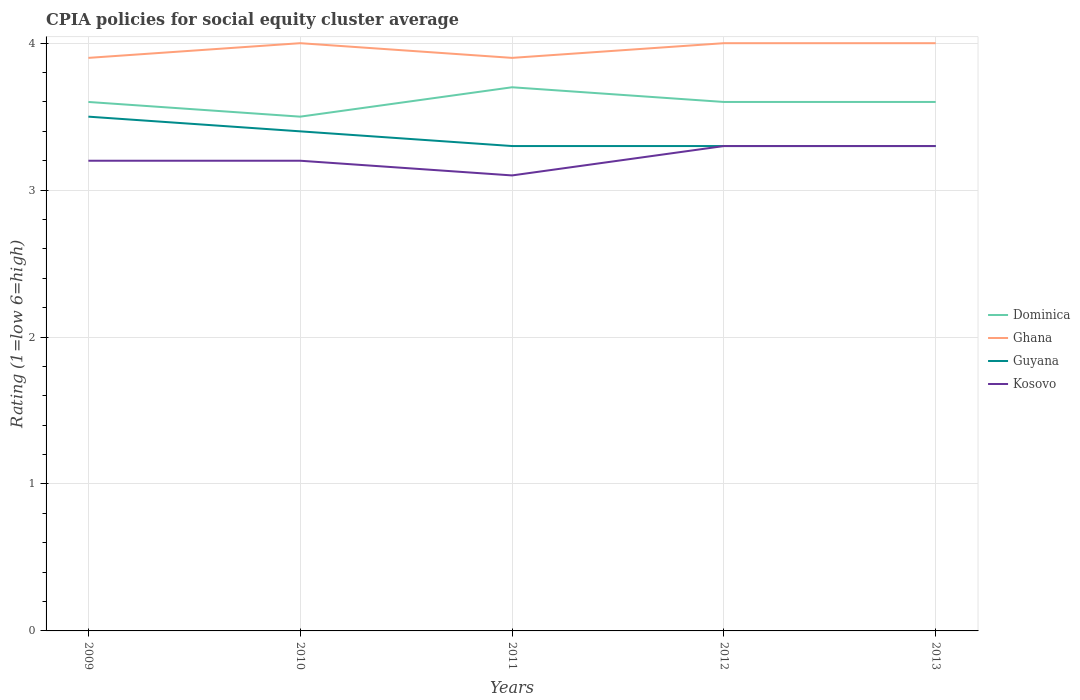Does the line corresponding to Ghana intersect with the line corresponding to Kosovo?
Make the answer very short. No. Is the number of lines equal to the number of legend labels?
Your answer should be compact. Yes. Across all years, what is the maximum CPIA rating in Dominica?
Provide a succinct answer. 3.5. What is the total CPIA rating in Ghana in the graph?
Ensure brevity in your answer.  0. What is the difference between the highest and the second highest CPIA rating in Guyana?
Your response must be concise. 0.2. What is the difference between the highest and the lowest CPIA rating in Kosovo?
Provide a succinct answer. 2. How many years are there in the graph?
Offer a very short reply. 5. Are the values on the major ticks of Y-axis written in scientific E-notation?
Your answer should be very brief. No. Does the graph contain any zero values?
Give a very brief answer. No. What is the title of the graph?
Offer a very short reply. CPIA policies for social equity cluster average. What is the Rating (1=low 6=high) of Guyana in 2009?
Offer a very short reply. 3.5. What is the Rating (1=low 6=high) of Dominica in 2010?
Your answer should be compact. 3.5. What is the Rating (1=low 6=high) in Ghana in 2011?
Your answer should be very brief. 3.9. What is the Rating (1=low 6=high) of Guyana in 2011?
Your answer should be very brief. 3.3. What is the Rating (1=low 6=high) of Dominica in 2012?
Give a very brief answer. 3.6. What is the Rating (1=low 6=high) of Guyana in 2012?
Provide a succinct answer. 3.3. What is the Rating (1=low 6=high) of Kosovo in 2012?
Your response must be concise. 3.3. What is the Rating (1=low 6=high) in Dominica in 2013?
Provide a short and direct response. 3.6. What is the Rating (1=low 6=high) of Kosovo in 2013?
Ensure brevity in your answer.  3.3. Across all years, what is the maximum Rating (1=low 6=high) of Guyana?
Give a very brief answer. 3.5. Across all years, what is the maximum Rating (1=low 6=high) of Kosovo?
Provide a succinct answer. 3.3. Across all years, what is the minimum Rating (1=low 6=high) in Dominica?
Offer a terse response. 3.5. Across all years, what is the minimum Rating (1=low 6=high) in Ghana?
Ensure brevity in your answer.  3.9. What is the total Rating (1=low 6=high) in Ghana in the graph?
Your answer should be compact. 19.8. What is the total Rating (1=low 6=high) of Kosovo in the graph?
Provide a succinct answer. 16.1. What is the difference between the Rating (1=low 6=high) in Dominica in 2009 and that in 2010?
Offer a very short reply. 0.1. What is the difference between the Rating (1=low 6=high) of Ghana in 2009 and that in 2010?
Give a very brief answer. -0.1. What is the difference between the Rating (1=low 6=high) in Kosovo in 2009 and that in 2010?
Offer a very short reply. 0. What is the difference between the Rating (1=low 6=high) of Dominica in 2009 and that in 2011?
Keep it short and to the point. -0.1. What is the difference between the Rating (1=low 6=high) in Guyana in 2009 and that in 2011?
Your response must be concise. 0.2. What is the difference between the Rating (1=low 6=high) of Dominica in 2009 and that in 2012?
Provide a short and direct response. 0. What is the difference between the Rating (1=low 6=high) of Ghana in 2009 and that in 2013?
Give a very brief answer. -0.1. What is the difference between the Rating (1=low 6=high) in Ghana in 2010 and that in 2011?
Ensure brevity in your answer.  0.1. What is the difference between the Rating (1=low 6=high) of Guyana in 2010 and that in 2011?
Your response must be concise. 0.1. What is the difference between the Rating (1=low 6=high) in Dominica in 2010 and that in 2012?
Offer a very short reply. -0.1. What is the difference between the Rating (1=low 6=high) in Dominica in 2010 and that in 2013?
Offer a very short reply. -0.1. What is the difference between the Rating (1=low 6=high) of Ghana in 2010 and that in 2013?
Your answer should be very brief. 0. What is the difference between the Rating (1=low 6=high) of Kosovo in 2010 and that in 2013?
Keep it short and to the point. -0.1. What is the difference between the Rating (1=low 6=high) of Ghana in 2011 and that in 2012?
Offer a terse response. -0.1. What is the difference between the Rating (1=low 6=high) of Guyana in 2011 and that in 2013?
Your answer should be very brief. 0. What is the difference between the Rating (1=low 6=high) of Dominica in 2012 and that in 2013?
Offer a terse response. 0. What is the difference between the Rating (1=low 6=high) of Kosovo in 2012 and that in 2013?
Offer a terse response. 0. What is the difference between the Rating (1=low 6=high) of Dominica in 2009 and the Rating (1=low 6=high) of Kosovo in 2010?
Give a very brief answer. 0.4. What is the difference between the Rating (1=low 6=high) in Ghana in 2009 and the Rating (1=low 6=high) in Kosovo in 2010?
Ensure brevity in your answer.  0.7. What is the difference between the Rating (1=low 6=high) of Guyana in 2009 and the Rating (1=low 6=high) of Kosovo in 2010?
Make the answer very short. 0.3. What is the difference between the Rating (1=low 6=high) in Dominica in 2009 and the Rating (1=low 6=high) in Ghana in 2011?
Offer a terse response. -0.3. What is the difference between the Rating (1=low 6=high) in Dominica in 2009 and the Rating (1=low 6=high) in Kosovo in 2011?
Provide a short and direct response. 0.5. What is the difference between the Rating (1=low 6=high) in Ghana in 2009 and the Rating (1=low 6=high) in Kosovo in 2011?
Provide a succinct answer. 0.8. What is the difference between the Rating (1=low 6=high) in Guyana in 2009 and the Rating (1=low 6=high) in Kosovo in 2011?
Make the answer very short. 0.4. What is the difference between the Rating (1=low 6=high) in Dominica in 2009 and the Rating (1=low 6=high) in Ghana in 2012?
Provide a succinct answer. -0.4. What is the difference between the Rating (1=low 6=high) in Dominica in 2009 and the Rating (1=low 6=high) in Guyana in 2012?
Offer a terse response. 0.3. What is the difference between the Rating (1=low 6=high) in Ghana in 2009 and the Rating (1=low 6=high) in Guyana in 2012?
Give a very brief answer. 0.6. What is the difference between the Rating (1=low 6=high) in Dominica in 2009 and the Rating (1=low 6=high) in Ghana in 2013?
Give a very brief answer. -0.4. What is the difference between the Rating (1=low 6=high) of Dominica in 2009 and the Rating (1=low 6=high) of Guyana in 2013?
Your answer should be compact. 0.3. What is the difference between the Rating (1=low 6=high) in Ghana in 2009 and the Rating (1=low 6=high) in Guyana in 2013?
Make the answer very short. 0.6. What is the difference between the Rating (1=low 6=high) in Dominica in 2010 and the Rating (1=low 6=high) in Guyana in 2011?
Your answer should be compact. 0.2. What is the difference between the Rating (1=low 6=high) in Dominica in 2010 and the Rating (1=low 6=high) in Guyana in 2012?
Ensure brevity in your answer.  0.2. What is the difference between the Rating (1=low 6=high) in Ghana in 2010 and the Rating (1=low 6=high) in Kosovo in 2012?
Provide a succinct answer. 0.7. What is the difference between the Rating (1=low 6=high) of Guyana in 2010 and the Rating (1=low 6=high) of Kosovo in 2012?
Give a very brief answer. 0.1. What is the difference between the Rating (1=low 6=high) in Dominica in 2010 and the Rating (1=low 6=high) in Kosovo in 2013?
Provide a succinct answer. 0.2. What is the difference between the Rating (1=low 6=high) of Ghana in 2010 and the Rating (1=low 6=high) of Guyana in 2013?
Your answer should be compact. 0.7. What is the difference between the Rating (1=low 6=high) of Ghana in 2010 and the Rating (1=low 6=high) of Kosovo in 2013?
Keep it short and to the point. 0.7. What is the difference between the Rating (1=low 6=high) in Dominica in 2011 and the Rating (1=low 6=high) in Ghana in 2012?
Offer a terse response. -0.3. What is the difference between the Rating (1=low 6=high) in Ghana in 2011 and the Rating (1=low 6=high) in Guyana in 2012?
Your response must be concise. 0.6. What is the difference between the Rating (1=low 6=high) of Dominica in 2011 and the Rating (1=low 6=high) of Ghana in 2013?
Provide a succinct answer. -0.3. What is the difference between the Rating (1=low 6=high) of Dominica in 2011 and the Rating (1=low 6=high) of Guyana in 2013?
Your response must be concise. 0.4. What is the difference between the Rating (1=low 6=high) in Ghana in 2011 and the Rating (1=low 6=high) in Guyana in 2013?
Offer a terse response. 0.6. What is the difference between the Rating (1=low 6=high) of Ghana in 2011 and the Rating (1=low 6=high) of Kosovo in 2013?
Provide a short and direct response. 0.6. What is the difference between the Rating (1=low 6=high) of Guyana in 2011 and the Rating (1=low 6=high) of Kosovo in 2013?
Your response must be concise. 0. What is the difference between the Rating (1=low 6=high) of Dominica in 2012 and the Rating (1=low 6=high) of Ghana in 2013?
Provide a short and direct response. -0.4. What is the difference between the Rating (1=low 6=high) in Ghana in 2012 and the Rating (1=low 6=high) in Kosovo in 2013?
Offer a very short reply. 0.7. What is the difference between the Rating (1=low 6=high) of Guyana in 2012 and the Rating (1=low 6=high) of Kosovo in 2013?
Provide a short and direct response. 0. What is the average Rating (1=low 6=high) of Dominica per year?
Your answer should be compact. 3.6. What is the average Rating (1=low 6=high) of Ghana per year?
Offer a very short reply. 3.96. What is the average Rating (1=low 6=high) of Guyana per year?
Make the answer very short. 3.36. What is the average Rating (1=low 6=high) in Kosovo per year?
Offer a terse response. 3.22. In the year 2009, what is the difference between the Rating (1=low 6=high) in Dominica and Rating (1=low 6=high) in Kosovo?
Keep it short and to the point. 0.4. In the year 2009, what is the difference between the Rating (1=low 6=high) in Ghana and Rating (1=low 6=high) in Guyana?
Offer a terse response. 0.4. In the year 2009, what is the difference between the Rating (1=low 6=high) in Guyana and Rating (1=low 6=high) in Kosovo?
Offer a very short reply. 0.3. In the year 2010, what is the difference between the Rating (1=low 6=high) in Dominica and Rating (1=low 6=high) in Guyana?
Keep it short and to the point. 0.1. In the year 2010, what is the difference between the Rating (1=low 6=high) of Dominica and Rating (1=low 6=high) of Kosovo?
Make the answer very short. 0.3. In the year 2010, what is the difference between the Rating (1=low 6=high) in Guyana and Rating (1=low 6=high) in Kosovo?
Provide a succinct answer. 0.2. In the year 2011, what is the difference between the Rating (1=low 6=high) of Ghana and Rating (1=low 6=high) of Guyana?
Offer a terse response. 0.6. In the year 2011, what is the difference between the Rating (1=low 6=high) in Ghana and Rating (1=low 6=high) in Kosovo?
Your response must be concise. 0.8. In the year 2012, what is the difference between the Rating (1=low 6=high) of Dominica and Rating (1=low 6=high) of Ghana?
Keep it short and to the point. -0.4. In the year 2012, what is the difference between the Rating (1=low 6=high) of Dominica and Rating (1=low 6=high) of Guyana?
Your answer should be compact. 0.3. In the year 2012, what is the difference between the Rating (1=low 6=high) in Dominica and Rating (1=low 6=high) in Kosovo?
Provide a short and direct response. 0.3. In the year 2012, what is the difference between the Rating (1=low 6=high) of Ghana and Rating (1=low 6=high) of Guyana?
Offer a very short reply. 0.7. In the year 2012, what is the difference between the Rating (1=low 6=high) in Ghana and Rating (1=low 6=high) in Kosovo?
Keep it short and to the point. 0.7. In the year 2012, what is the difference between the Rating (1=low 6=high) in Guyana and Rating (1=low 6=high) in Kosovo?
Offer a very short reply. 0. In the year 2013, what is the difference between the Rating (1=low 6=high) of Dominica and Rating (1=low 6=high) of Ghana?
Offer a very short reply. -0.4. In the year 2013, what is the difference between the Rating (1=low 6=high) in Dominica and Rating (1=low 6=high) in Kosovo?
Provide a short and direct response. 0.3. In the year 2013, what is the difference between the Rating (1=low 6=high) of Guyana and Rating (1=low 6=high) of Kosovo?
Offer a terse response. 0. What is the ratio of the Rating (1=low 6=high) of Dominica in 2009 to that in 2010?
Provide a short and direct response. 1.03. What is the ratio of the Rating (1=low 6=high) of Guyana in 2009 to that in 2010?
Offer a very short reply. 1.03. What is the ratio of the Rating (1=low 6=high) in Kosovo in 2009 to that in 2010?
Keep it short and to the point. 1. What is the ratio of the Rating (1=low 6=high) in Guyana in 2009 to that in 2011?
Offer a very short reply. 1.06. What is the ratio of the Rating (1=low 6=high) of Kosovo in 2009 to that in 2011?
Ensure brevity in your answer.  1.03. What is the ratio of the Rating (1=low 6=high) in Dominica in 2009 to that in 2012?
Offer a terse response. 1. What is the ratio of the Rating (1=low 6=high) of Ghana in 2009 to that in 2012?
Provide a short and direct response. 0.97. What is the ratio of the Rating (1=low 6=high) of Guyana in 2009 to that in 2012?
Make the answer very short. 1.06. What is the ratio of the Rating (1=low 6=high) of Kosovo in 2009 to that in 2012?
Provide a short and direct response. 0.97. What is the ratio of the Rating (1=low 6=high) in Dominica in 2009 to that in 2013?
Provide a short and direct response. 1. What is the ratio of the Rating (1=low 6=high) in Ghana in 2009 to that in 2013?
Offer a very short reply. 0.97. What is the ratio of the Rating (1=low 6=high) in Guyana in 2009 to that in 2013?
Your answer should be compact. 1.06. What is the ratio of the Rating (1=low 6=high) of Kosovo in 2009 to that in 2013?
Your response must be concise. 0.97. What is the ratio of the Rating (1=low 6=high) of Dominica in 2010 to that in 2011?
Offer a terse response. 0.95. What is the ratio of the Rating (1=low 6=high) of Ghana in 2010 to that in 2011?
Make the answer very short. 1.03. What is the ratio of the Rating (1=low 6=high) in Guyana in 2010 to that in 2011?
Provide a succinct answer. 1.03. What is the ratio of the Rating (1=low 6=high) of Kosovo in 2010 to that in 2011?
Provide a succinct answer. 1.03. What is the ratio of the Rating (1=low 6=high) in Dominica in 2010 to that in 2012?
Your response must be concise. 0.97. What is the ratio of the Rating (1=low 6=high) in Ghana in 2010 to that in 2012?
Your response must be concise. 1. What is the ratio of the Rating (1=low 6=high) of Guyana in 2010 to that in 2012?
Provide a succinct answer. 1.03. What is the ratio of the Rating (1=low 6=high) in Kosovo in 2010 to that in 2012?
Your answer should be very brief. 0.97. What is the ratio of the Rating (1=low 6=high) of Dominica in 2010 to that in 2013?
Keep it short and to the point. 0.97. What is the ratio of the Rating (1=low 6=high) in Guyana in 2010 to that in 2013?
Your answer should be very brief. 1.03. What is the ratio of the Rating (1=low 6=high) in Kosovo in 2010 to that in 2013?
Your answer should be compact. 0.97. What is the ratio of the Rating (1=low 6=high) of Dominica in 2011 to that in 2012?
Offer a terse response. 1.03. What is the ratio of the Rating (1=low 6=high) of Guyana in 2011 to that in 2012?
Give a very brief answer. 1. What is the ratio of the Rating (1=low 6=high) in Kosovo in 2011 to that in 2012?
Your answer should be compact. 0.94. What is the ratio of the Rating (1=low 6=high) of Dominica in 2011 to that in 2013?
Ensure brevity in your answer.  1.03. What is the ratio of the Rating (1=low 6=high) in Kosovo in 2011 to that in 2013?
Provide a short and direct response. 0.94. What is the ratio of the Rating (1=low 6=high) of Ghana in 2012 to that in 2013?
Give a very brief answer. 1. What is the ratio of the Rating (1=low 6=high) of Kosovo in 2012 to that in 2013?
Make the answer very short. 1. What is the difference between the highest and the second highest Rating (1=low 6=high) in Dominica?
Provide a succinct answer. 0.1. What is the difference between the highest and the second highest Rating (1=low 6=high) of Kosovo?
Provide a short and direct response. 0. What is the difference between the highest and the lowest Rating (1=low 6=high) of Dominica?
Give a very brief answer. 0.2. What is the difference between the highest and the lowest Rating (1=low 6=high) of Ghana?
Keep it short and to the point. 0.1. What is the difference between the highest and the lowest Rating (1=low 6=high) in Guyana?
Provide a short and direct response. 0.2. 